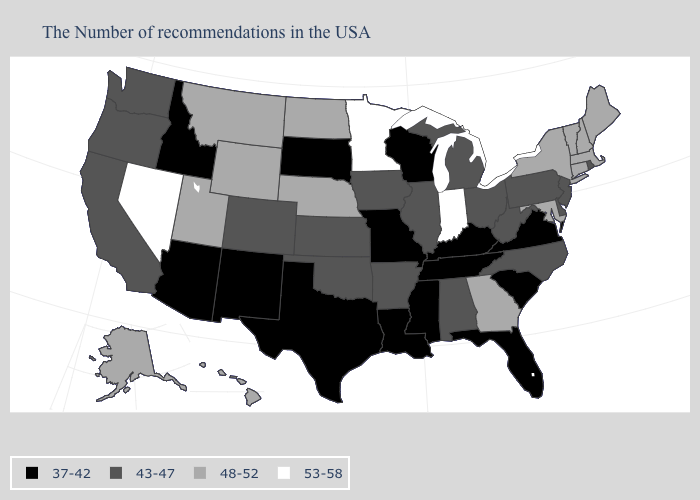What is the value of Wisconsin?
Concise answer only. 37-42. Name the states that have a value in the range 37-42?
Write a very short answer. Virginia, South Carolina, Florida, Kentucky, Tennessee, Wisconsin, Mississippi, Louisiana, Missouri, Texas, South Dakota, New Mexico, Arizona, Idaho. Name the states that have a value in the range 53-58?
Keep it brief. Indiana, Minnesota, Nevada. Is the legend a continuous bar?
Keep it brief. No. What is the value of Tennessee?
Write a very short answer. 37-42. Name the states that have a value in the range 43-47?
Answer briefly. Rhode Island, New Jersey, Delaware, Pennsylvania, North Carolina, West Virginia, Ohio, Michigan, Alabama, Illinois, Arkansas, Iowa, Kansas, Oklahoma, Colorado, California, Washington, Oregon. Name the states that have a value in the range 43-47?
Short answer required. Rhode Island, New Jersey, Delaware, Pennsylvania, North Carolina, West Virginia, Ohio, Michigan, Alabama, Illinois, Arkansas, Iowa, Kansas, Oklahoma, Colorado, California, Washington, Oregon. Does North Carolina have the highest value in the South?
Keep it brief. No. What is the value of Rhode Island?
Short answer required. 43-47. What is the highest value in the USA?
Short answer required. 53-58. Name the states that have a value in the range 48-52?
Short answer required. Maine, Massachusetts, New Hampshire, Vermont, Connecticut, New York, Maryland, Georgia, Nebraska, North Dakota, Wyoming, Utah, Montana, Alaska, Hawaii. What is the value of New Mexico?
Write a very short answer. 37-42. Among the states that border Georgia , which have the highest value?
Concise answer only. North Carolina, Alabama. Does Maine have the same value as Massachusetts?
Keep it brief. Yes. Name the states that have a value in the range 53-58?
Keep it brief. Indiana, Minnesota, Nevada. 